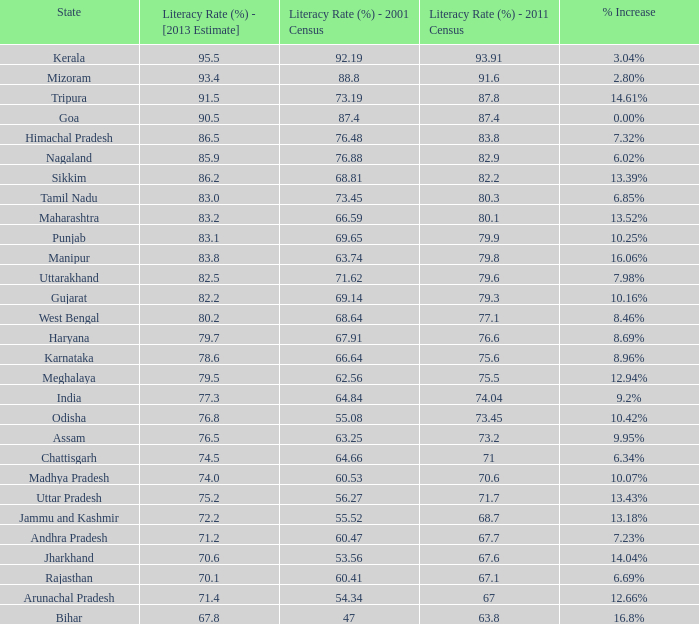For states with a literacy rate greater than 73.2% in 2011, lower than 68.81% in 2001, and an estimated 76.8% rate in 2013, what is the average literacy increase? 10.42%. 